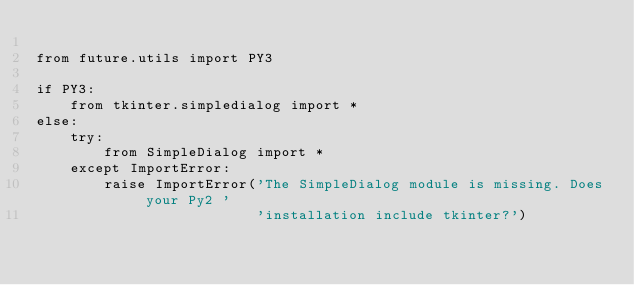<code> <loc_0><loc_0><loc_500><loc_500><_Python_>
from future.utils import PY3

if PY3:
    from tkinter.simpledialog import *
else:
    try:
        from SimpleDialog import *
    except ImportError:
        raise ImportError('The SimpleDialog module is missing. Does your Py2 '
                          'installation include tkinter?')

</code> 